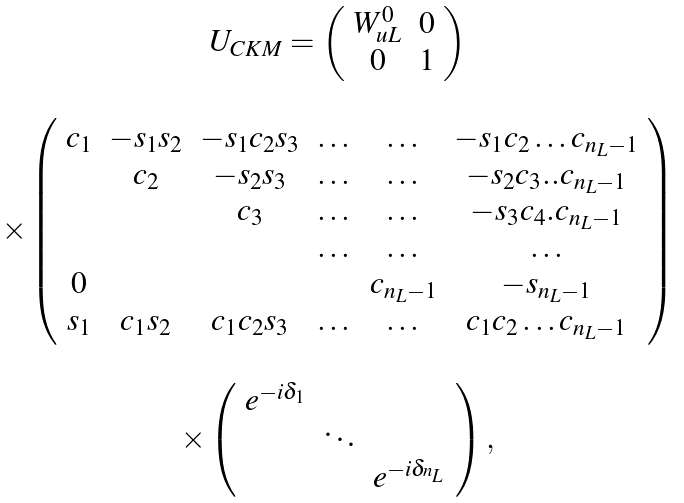<formula> <loc_0><loc_0><loc_500><loc_500>\begin{array} { c c } U _ { C K M } = \left ( \begin{array} { c c } W _ { u L } ^ { 0 } & 0 \\ 0 & 1 \end{array} \right ) & \\ & \\ \times \left ( \begin{array} { c c c c c c } c _ { 1 } & - s _ { 1 } s _ { 2 } & - s _ { 1 } c _ { 2 } s _ { 3 } & \dots & \dots & - s _ { 1 } c _ { 2 } \dots c _ { n _ { L } - 1 } \\ & c _ { 2 } & - s _ { 2 } s _ { 3 } & \dots & \dots & - s _ { 2 } c _ { 3 } . . c _ { n _ { L } - 1 } \\ & & c _ { 3 } & \dots & \dots & - s _ { 3 } c _ { 4 } . c _ { n _ { L } - 1 } \\ & & & \dots & \dots & \dots \\ 0 & & & & c _ { n _ { L } - 1 } & - s _ { n _ { L } - 1 } \\ s _ { 1 } & c _ { 1 } s _ { 2 } & c _ { 1 } c _ { 2 } s _ { 3 } & \dots & \dots & c _ { 1 } c _ { 2 } \dots c _ { n _ { L } - 1 } \end{array} \right ) & \\ & \\ \times \left ( \begin{array} { c c c } e ^ { - i \delta _ { 1 } } & & \\ & \ddots & \\ & & e ^ { - i \delta _ { ^ { n _ { L } } } } \end{array} \right ) , & \end{array}</formula> 